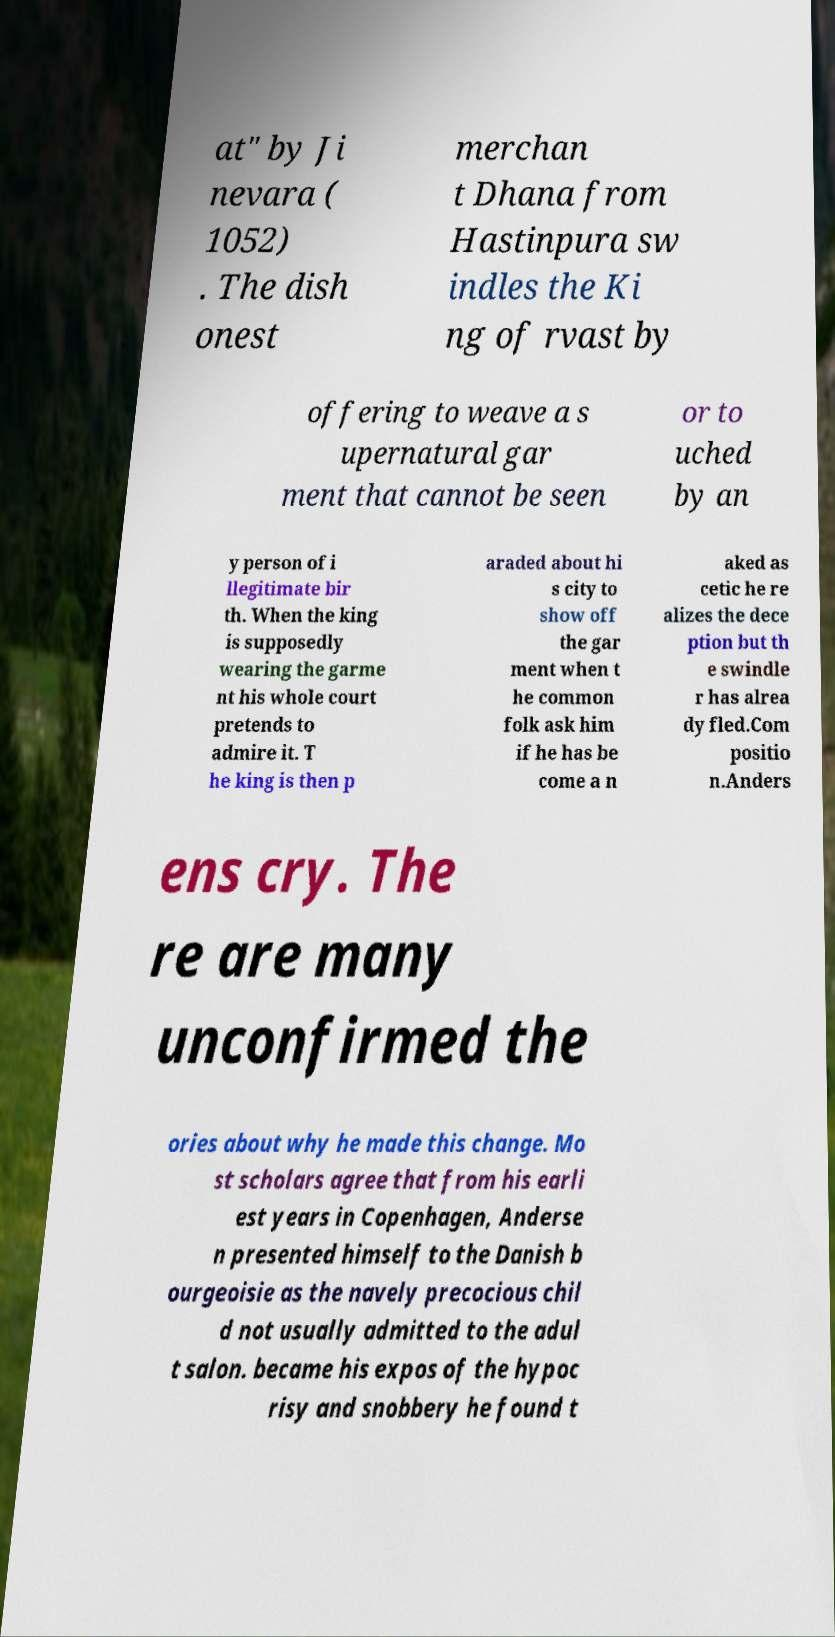For documentation purposes, I need the text within this image transcribed. Could you provide that? at" by Ji nevara ( 1052) . The dish onest merchan t Dhana from Hastinpura sw indles the Ki ng of rvast by offering to weave a s upernatural gar ment that cannot be seen or to uched by an y person of i llegitimate bir th. When the king is supposedly wearing the garme nt his whole court pretends to admire it. T he king is then p araded about hi s city to show off the gar ment when t he common folk ask him if he has be come a n aked as cetic he re alizes the dece ption but th e swindle r has alrea dy fled.Com positio n.Anders ens cry. The re are many unconfirmed the ories about why he made this change. Mo st scholars agree that from his earli est years in Copenhagen, Anderse n presented himself to the Danish b ourgeoisie as the navely precocious chil d not usually admitted to the adul t salon. became his expos of the hypoc risy and snobbery he found t 